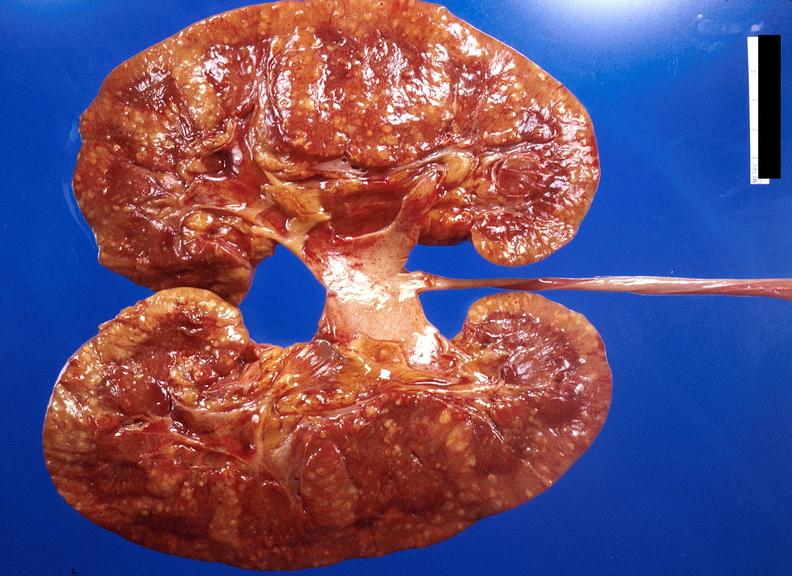does this image show kidney, candida abscesses?
Answer the question using a single word or phrase. Yes 